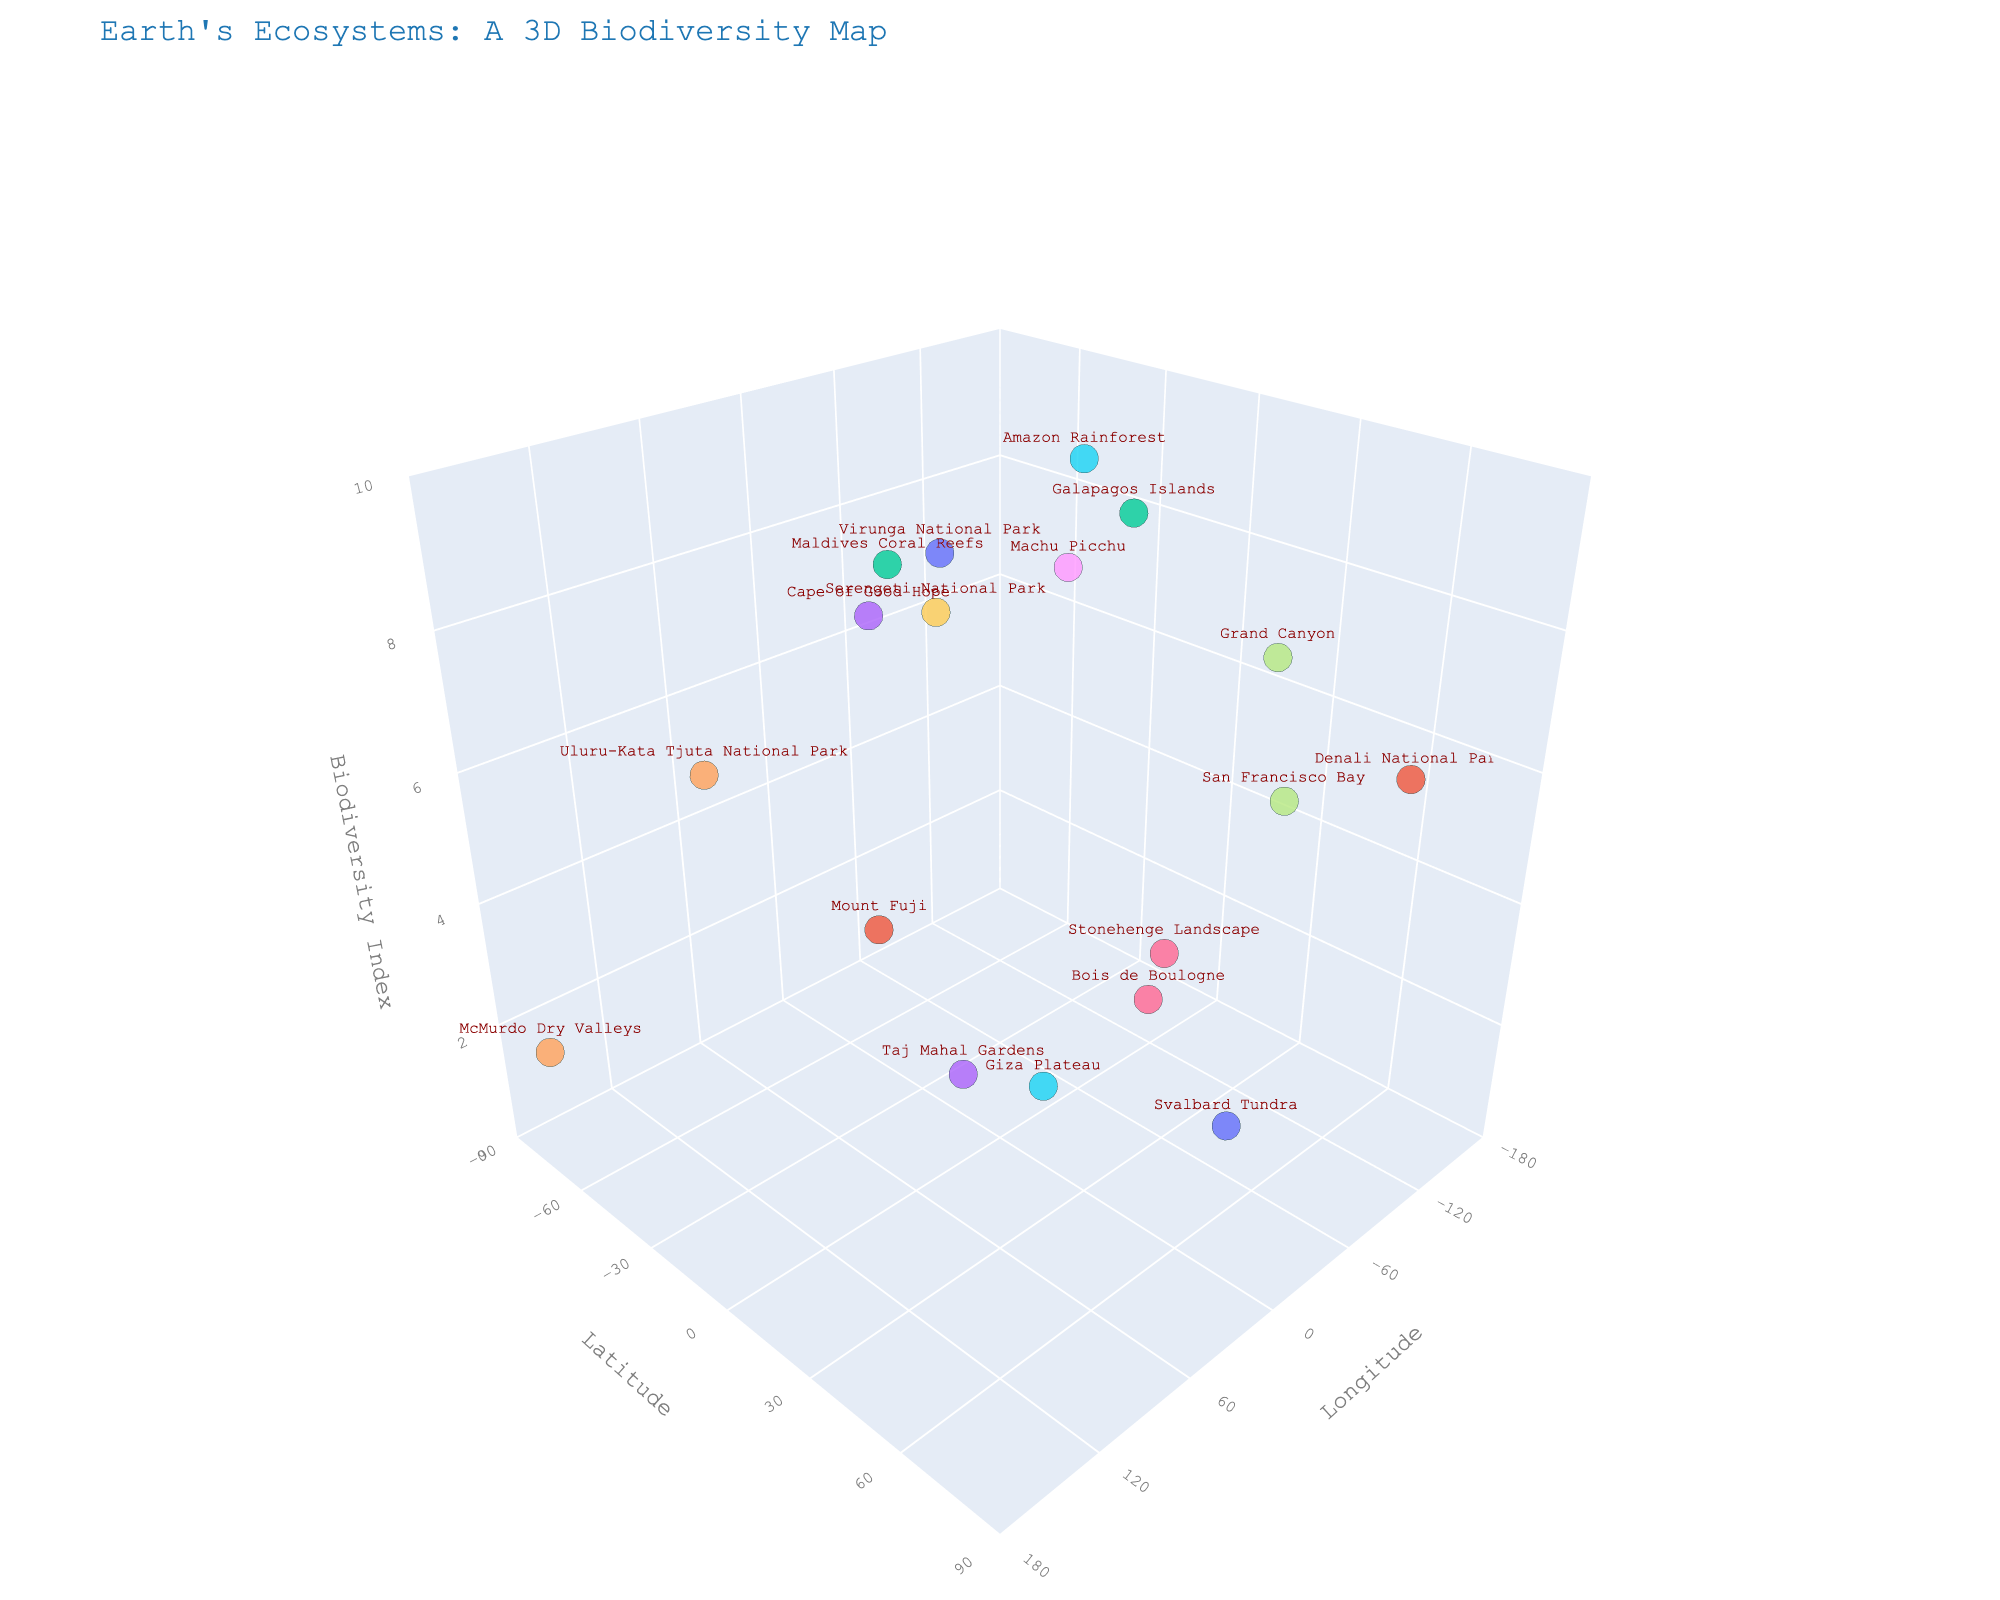What is the title of the 3D scatter plot? The title is usually centered at the top of the plot and describes the main subject of the visualization. You can refer to the top part of the figure to find this information.
Answer: Earth's Ecosystems: A 3D Biodiversity Map What are the axes labels in the plot? Axis labels can be seen beside the axes, providing information about what each axis represents. Look for text near the x, y, and z lines.
Answer: Longitude, Latitude, Biodiversity Index How many ecosystems are plotted in the figure? Count each distinct data point on the plot. Each ecosystem is represented by a different point and is identifiable via hover text.
Answer: 18 Which ecosystem has the highest Biodiversity Index? The highest Biodiversity Index would be the data point placed the highest along the z-axis. You can hover over the points to identify which ecosystem this corresponds to.
Answer: Amazon Rainforest What is the range of the Biodiversity Index in this plot? The range can be determined by identifying the minimum and maximum values of the z-axis, denoted by the lowest and highest points on this axis.
Answer: 1.7 to 9.8 What is the biodiversity index value and coordinates of the McMurdo Dry Valleys? Locate the McMurdo Dry Valleys on the figure by hovering over the data points, then read off its Biodiversity Index and coordinates from the plot.
Answer: 1.7, -77.8460, 166.6753 Which ecosystems have a Biodiversity Index greater than 7 but less than 9? Look for data points within the range of 7 to 9 on the z-axis. Hover over them to identify the ecosystems they represent.
Answer: Grand Canyon, Serengeti National Park, Machu Picchu, Cape of Good Hope What is the average Biodiversity Index for the plotted ecosystems? Sum all Biodiversity Index values and divide by the number of ecosystems (18 in this case). Calculate (9.2 + 5.7 + 8.9 + 3.1 + 6.8 + 9.8 + 4.5 + 7.3 + 8.1 + 8.5 + 2.9 + 6.2 + 9.5 + 7.8 + 1.7 + 2.3 + 3.8 + 5.1)/18.
Answer: 6.1 Compare the Latitude of Virunga National Park and Grand Canyon. Which one is more to the North? Identify the Latitude of both ecosystems by hovering over their respective points and compare the numerical values. The higher the value, the more North it is.
Answer: Grand Canyon 